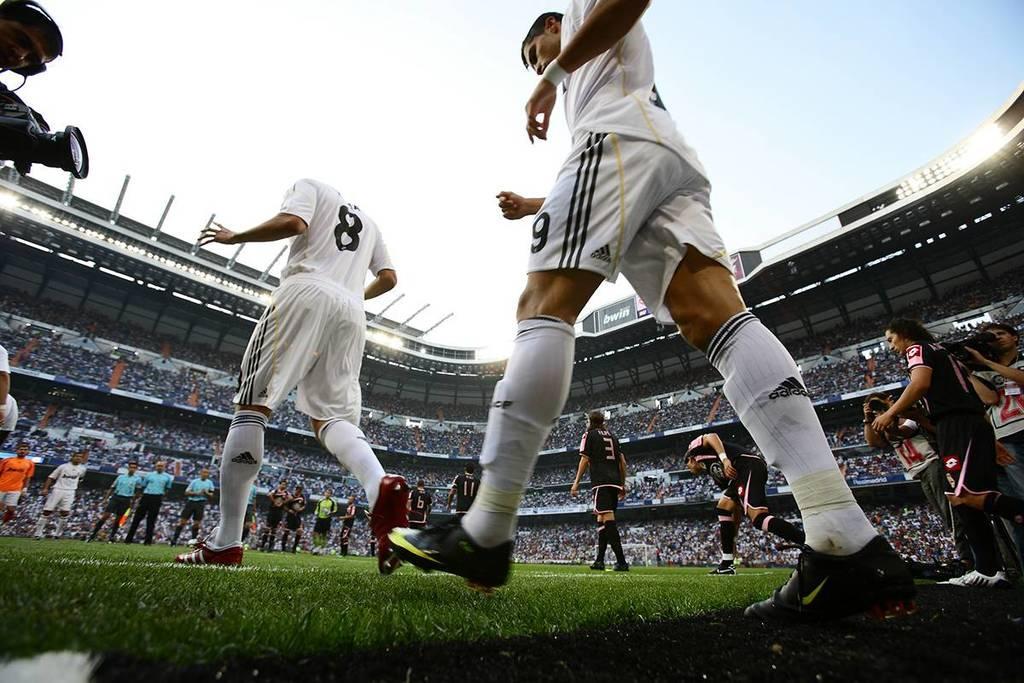Can you describe this image briefly? In this image I can see grass ground and on it I can see number of people are standing. I can see few of them are wearing white colour dress, few are wearing blue and rest all are wearing black colour dress. I can also see a camera over here and I can see few of them are wearing football shoes. In the background I can see number of lights. 